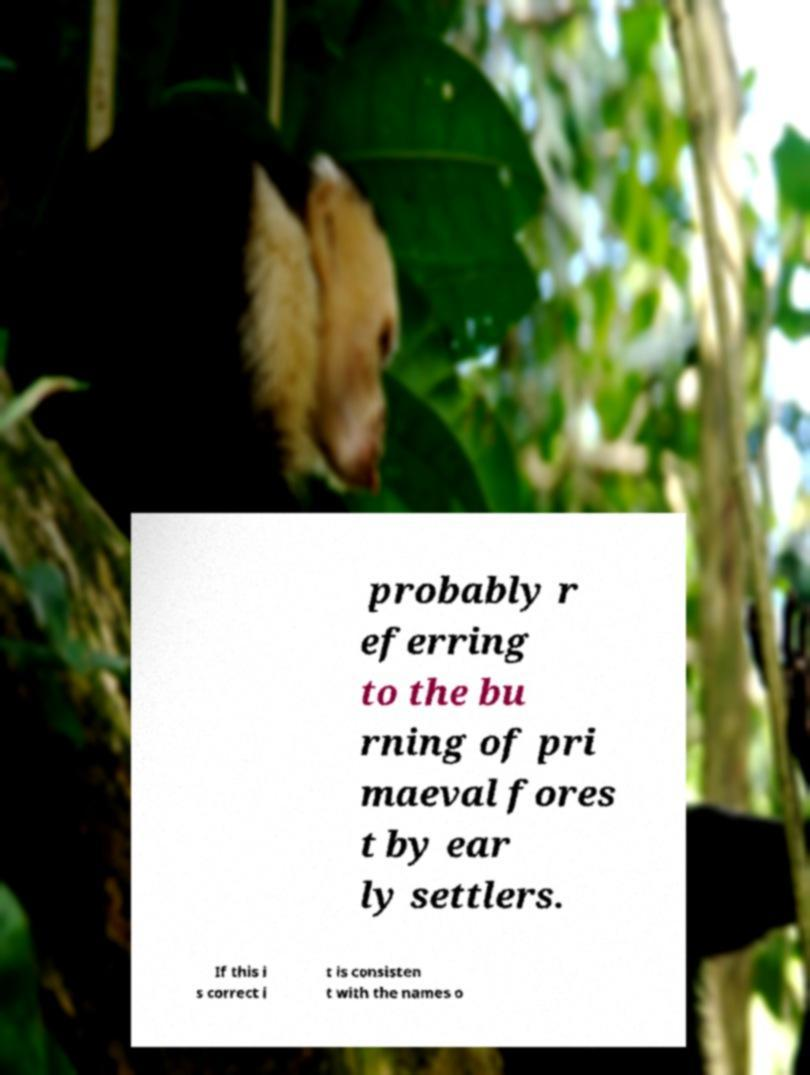Can you accurately transcribe the text from the provided image for me? probably r eferring to the bu rning of pri maeval fores t by ear ly settlers. If this i s correct i t is consisten t with the names o 